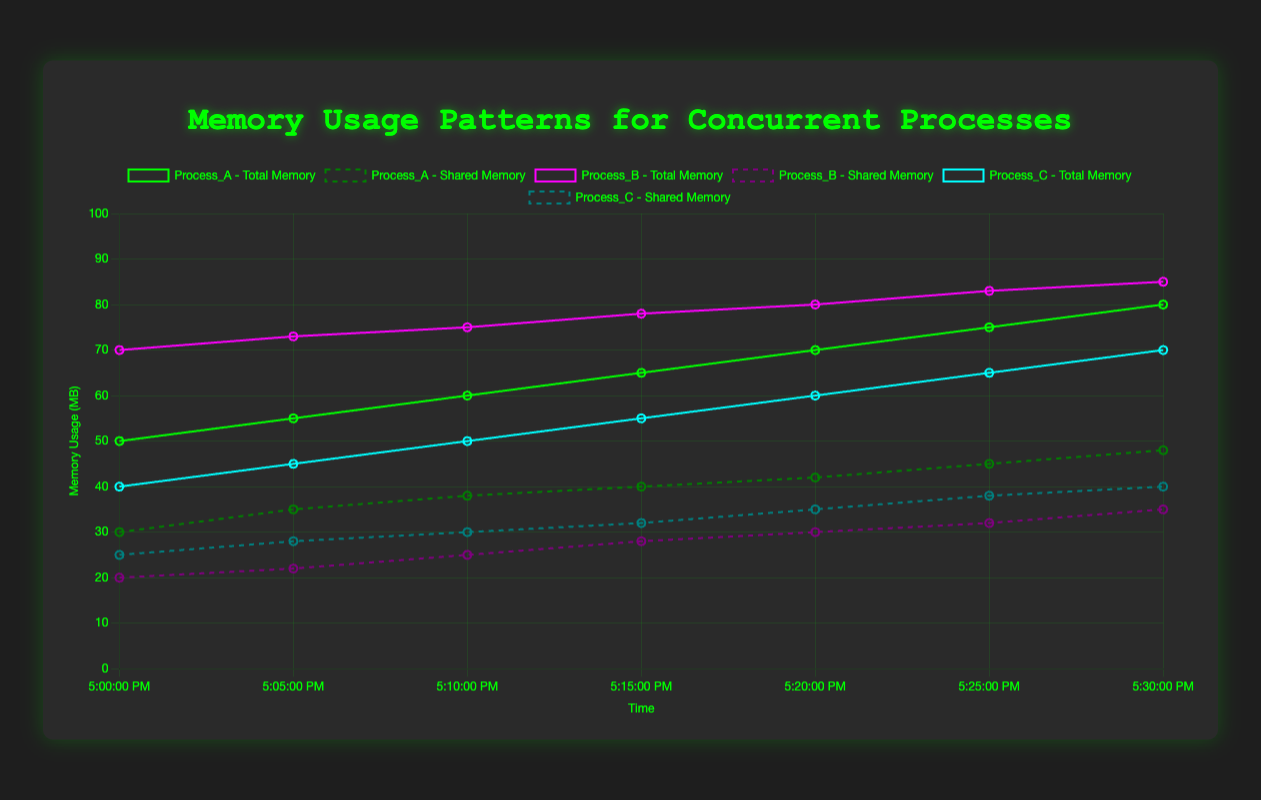What is the total memory usage of Process_A at 00:15? At 00:15, the total memory usage for Process_A includes both total memory and shared memory. For Process_A, the memory usage is 65 MB. The shared memory usage is 40 MB. The total memory usage is the sum of these values, which is 65 + 40 = 105 MB.
Answer: 105 MB Which process has the highest total memory usage at 00:10? At 00:10, the memory usages for Process_A, Process_B, and Process_C are 60 MB, 75 MB, and 50 MB respectively. Process_B has the highest memory usage of 75 MB.
Answer: Process_B What is the average shared memory usage for Process_C over the given period? To find the average shared memory usage for Process_C, sum the shared memory values at each timestamp and divide by the number of timestamps. The shared memory values for Process_C are 25, 28, 30, 32, 35, 38, 40. The sum is 25 + 28 + 30 + 32 + 35 + 38 + 40 = 228. There are 7 timestamps, so the average is 228 / 7 = 32.57 MB.
Answer: 32.57 MB At which timestamp does Process_B reach its peak memory usage? Observing the memory usage of Process_B over time, the values are 70, 73, 75, 78, 80, 83, 85. The peak memory usage is 85 MB, which occurs at the last timestamp, 00:30.
Answer: 00:30 How does the shared memory usage trend differ between Process_A and Process_B? Comparing the shared memory usage trends for Process_A and Process_B:
- Process_A: 30, 35, 38, 40, 42, 45, 48 (an increasing trend)
- Process_B: 20, 22, 25, 28, 30, 32, 35 (an increasing trend)
Both processes have an increasing trend, but Process_A has a steeper increase compared to Process_B.
Answer: Both increase, Process_A increases more steeply What is the difference in total memory usage between Process_B and Process_C at 00:20? At 00:20, Process_B's memory usage is 80 MB, and Process_C's memory usage is 60 MB. The difference in total memory usage is 80 - 60 = 20 MB.
Answer: 20 MB Which process has the smallest shared memory usage at 00:00? At 00:00, the shared memory usages for Process_A, Process_B, and Process_C are 30 MB, 20 MB, and 25 MB respectively. Process_B has the smallest shared memory usage with 20 MB.
Answer: Process_B What is the overall trend in total memory usage for Process_A? Observing Process_A over time:
- 50, 55, 60, 65, 70, 75, 80
Process_A shows a consistently increasing trend in total memory usage over the given period.
Answer: Increasing trend What proportion of Process_C's total memory usage is shared memory at 00:25? At 00:25, Process_C's total memory usage is 65 MB and the shared memory usage is 38 MB. The proportion is calculated as (38 / 65) * 100 = 58.46%.
Answer: 58.46% By how much does the shared memory usage of Process_C increase from 00:15 to 00:30? At 00:15, Process_C's shared memory usage is 32 MB, and at 00:30, it is 40 MB. The increase is 40 - 32 = 8 MB.
Answer: 8 MB 